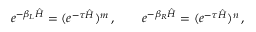<formula> <loc_0><loc_0><loc_500><loc_500>e ^ { - \beta _ { L } \hat { H } } = ( e ^ { - \tau \hat { H } } ) ^ { m } \, , \quad e ^ { - \beta _ { R } \hat { H } } = ( e ^ { - \tau \hat { H } } ) ^ { n } \, ,</formula> 